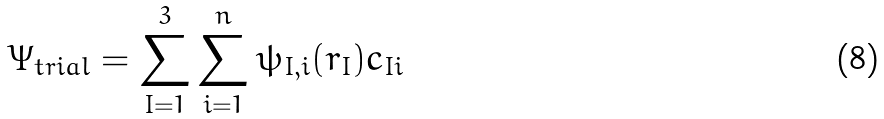<formula> <loc_0><loc_0><loc_500><loc_500>\Psi _ { t r i a l } = \sum _ { I = 1 } ^ { 3 } \sum _ { i = 1 } ^ { n } \psi _ { I , i } ( { r } _ { I } ) c _ { I i }</formula> 